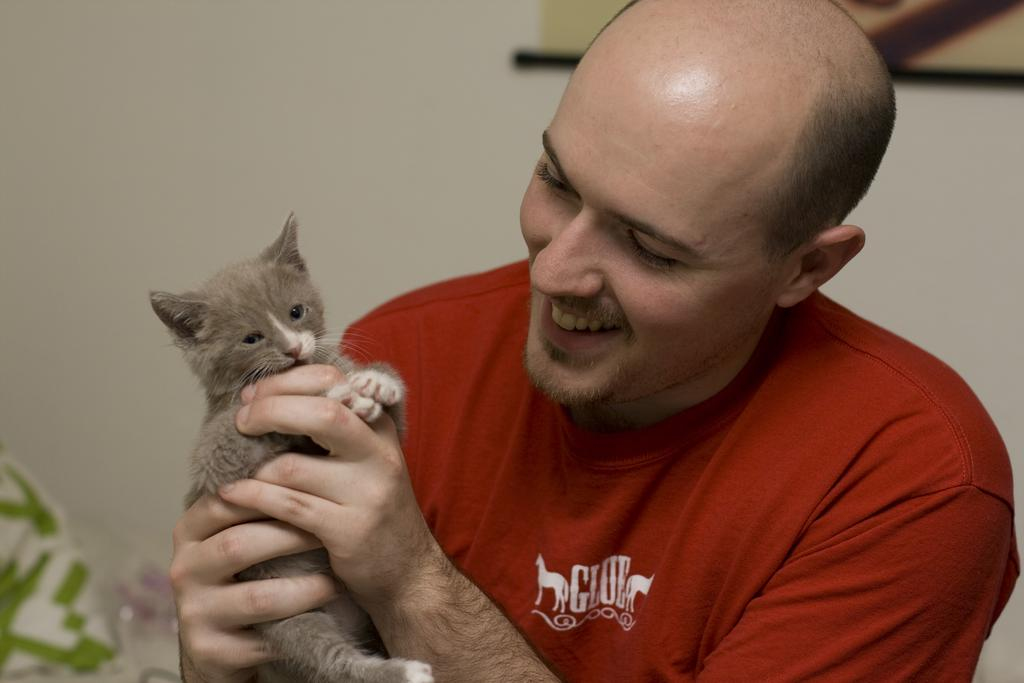What is the main subject of the image? There is a person in the image. What is the person doing in the image? The person is smiling. What is the person holding in the image? The person is holding a cat. What type of error can be seen in the image? There is no error present in the image; it features a person smiling and holding a cat. What is the relationship between the person and the air in the image? There is no specific relationship between the person and the air in the image; the person is simply holding a cat and smiling. 